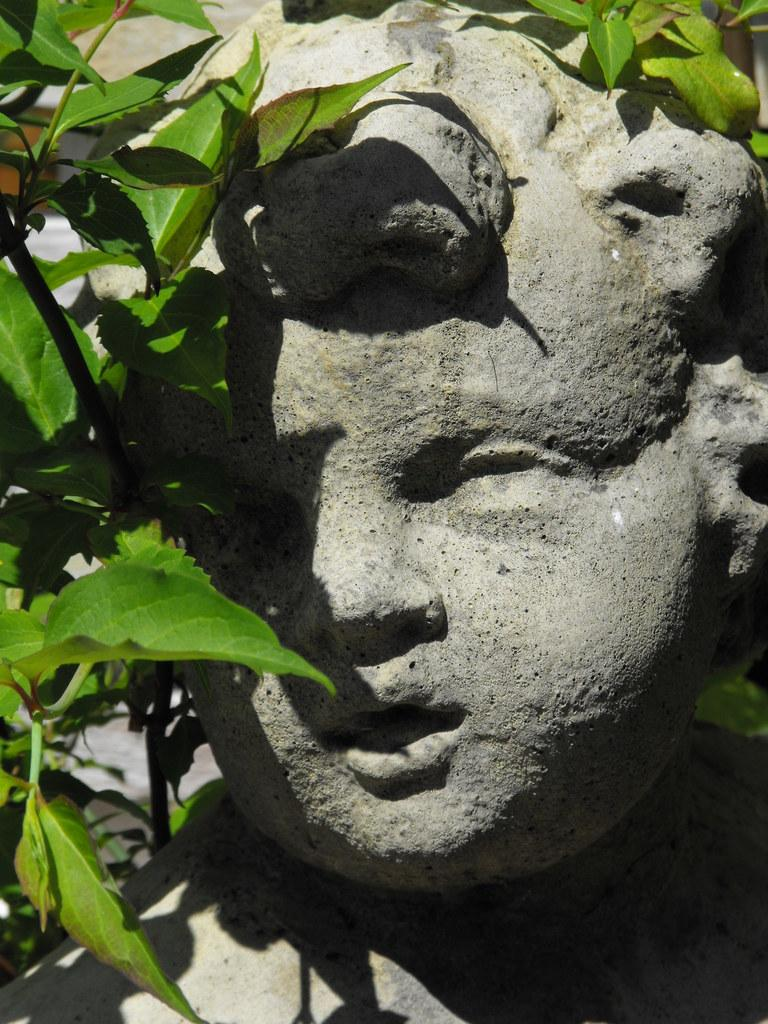What is the main subject of the image? There is a sculpture in the image. What can be seen around the sculpture? Leaves are visible around the sculpture. How many eyes can be seen on the sculpture in the image? There are no eyes visible on the sculpture in the image, as it is a sculpture and not a living being. 